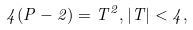<formula> <loc_0><loc_0><loc_500><loc_500>4 ( P - 2 ) = T ^ { 2 } , | T | < 4 ,</formula> 